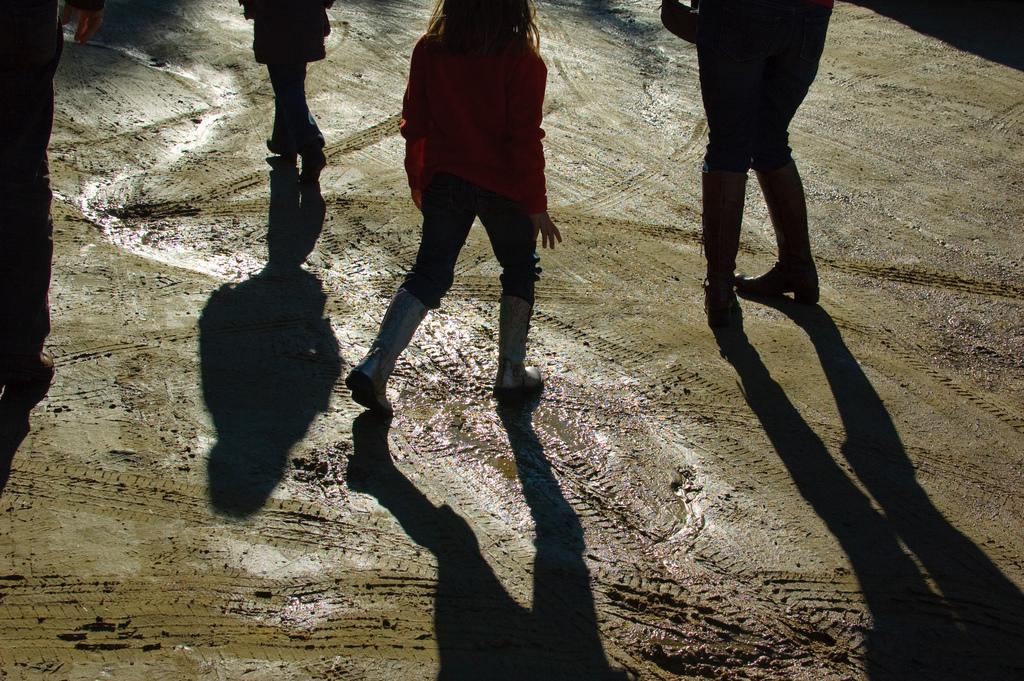How many people are in the image? There are people in the image, but the exact number is not specified. What can be observed about the people in the image? The shadows of the people are visible on the ground. What type of chalk is being used by the people in the image? There is no chalk present in the image; it only shows people and their shadows. 